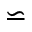<formula> <loc_0><loc_0><loc_500><loc_500>\backsimeq</formula> 